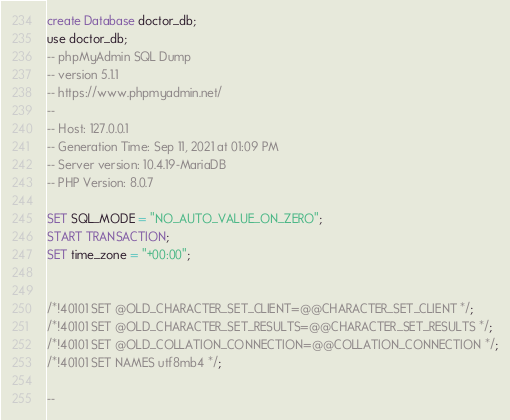Convert code to text. <code><loc_0><loc_0><loc_500><loc_500><_SQL_>create Database doctor_db;
use doctor_db;
-- phpMyAdmin SQL Dump
-- version 5.1.1
-- https://www.phpmyadmin.net/
--
-- Host: 127.0.0.1
-- Generation Time: Sep 11, 2021 at 01:09 PM
-- Server version: 10.4.19-MariaDB
-- PHP Version: 8.0.7

SET SQL_MODE = "NO_AUTO_VALUE_ON_ZERO";
START TRANSACTION;
SET time_zone = "+00:00";


/*!40101 SET @OLD_CHARACTER_SET_CLIENT=@@CHARACTER_SET_CLIENT */;
/*!40101 SET @OLD_CHARACTER_SET_RESULTS=@@CHARACTER_SET_RESULTS */;
/*!40101 SET @OLD_COLLATION_CONNECTION=@@COLLATION_CONNECTION */;
/*!40101 SET NAMES utf8mb4 */;

--</code> 